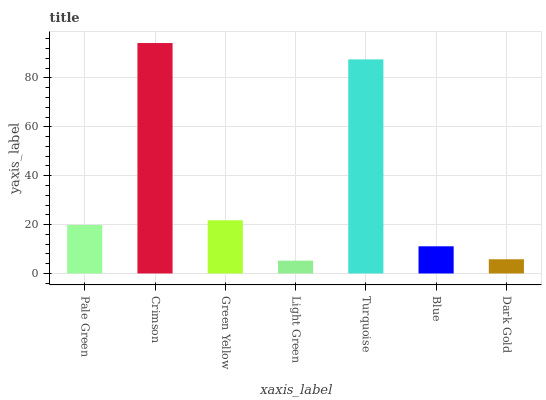Is Green Yellow the minimum?
Answer yes or no. No. Is Green Yellow the maximum?
Answer yes or no. No. Is Crimson greater than Green Yellow?
Answer yes or no. Yes. Is Green Yellow less than Crimson?
Answer yes or no. Yes. Is Green Yellow greater than Crimson?
Answer yes or no. No. Is Crimson less than Green Yellow?
Answer yes or no. No. Is Pale Green the high median?
Answer yes or no. Yes. Is Pale Green the low median?
Answer yes or no. Yes. Is Dark Gold the high median?
Answer yes or no. No. Is Turquoise the low median?
Answer yes or no. No. 